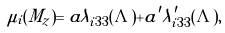<formula> <loc_0><loc_0><loc_500><loc_500>\mu _ { i } ( M _ { z } ) = a \lambda _ { i 3 3 } ( \Lambda ) + a ^ { \prime } \lambda ^ { \prime } _ { i 3 3 } ( \Lambda ) ,</formula> 